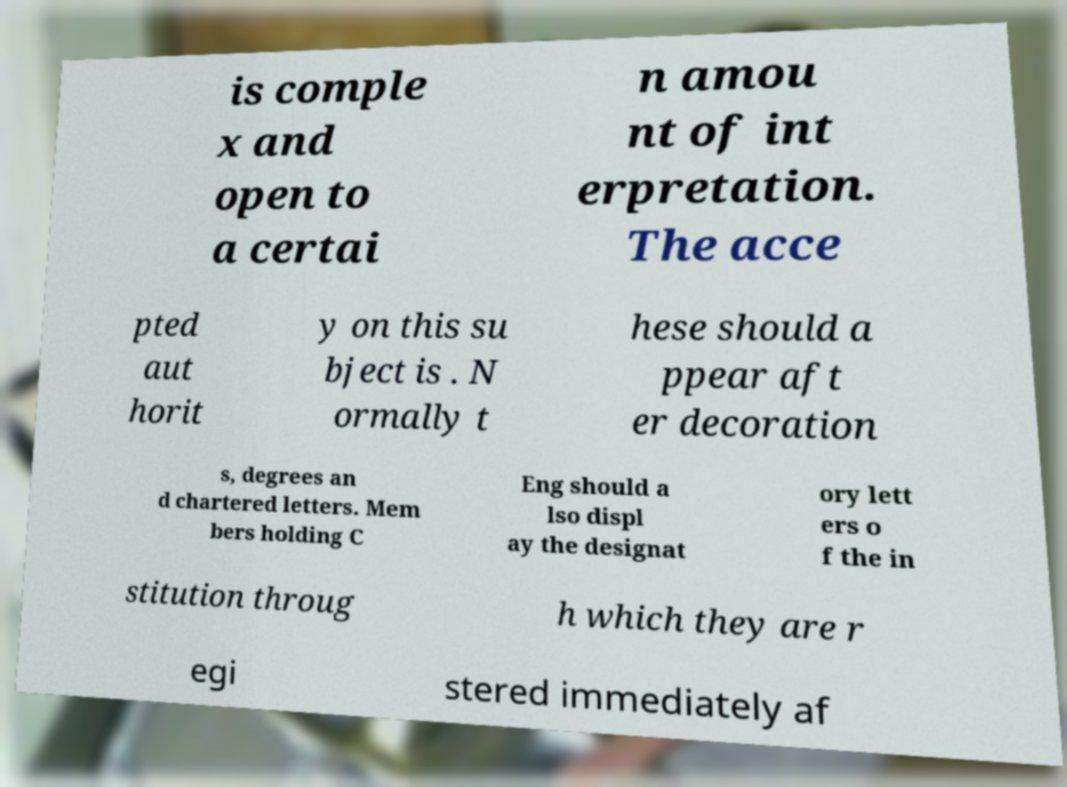Could you assist in decoding the text presented in this image and type it out clearly? is comple x and open to a certai n amou nt of int erpretation. The acce pted aut horit y on this su bject is . N ormally t hese should a ppear aft er decoration s, degrees an d chartered letters. Mem bers holding C Eng should a lso displ ay the designat ory lett ers o f the in stitution throug h which they are r egi stered immediately af 